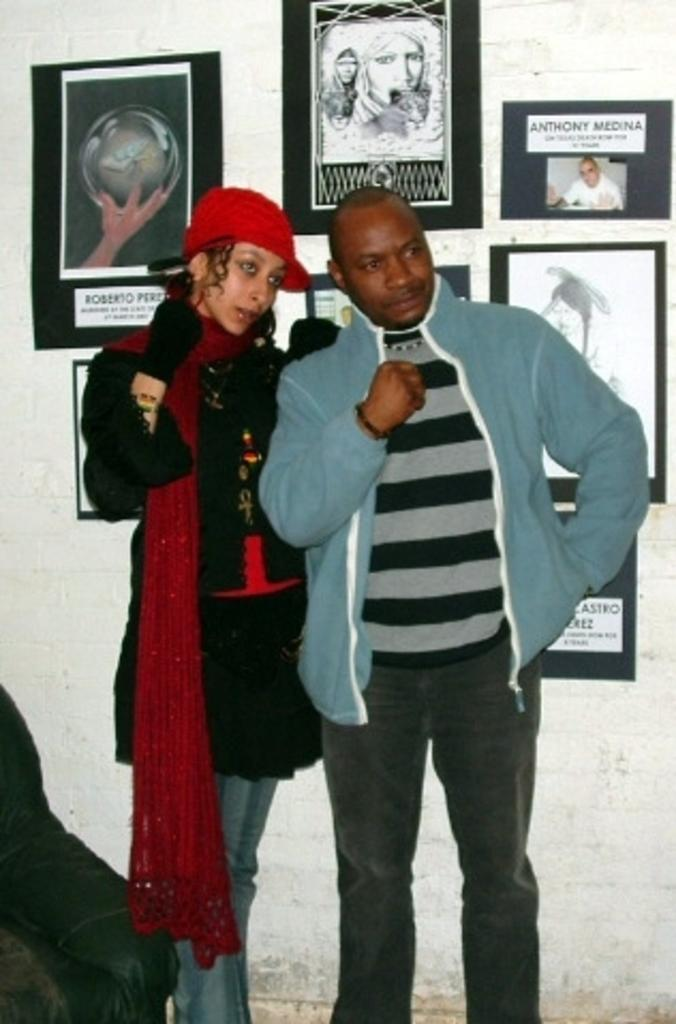How many people are present in the image? There are two people, a man and a woman, standing in the image. What is located on the left side of the image? There is an object on the left side of the image. What can be seen on the wall in the image? There are photo frames on the wall in the image. What type of owl can be seen sitting on the man's shoulder in the image? There is no owl present in the image; only the man and the woman are visible. What advice might the man's uncle give to the woman in the image? There is no uncle present in the image, so it is not possible to determine what advice he might give. 